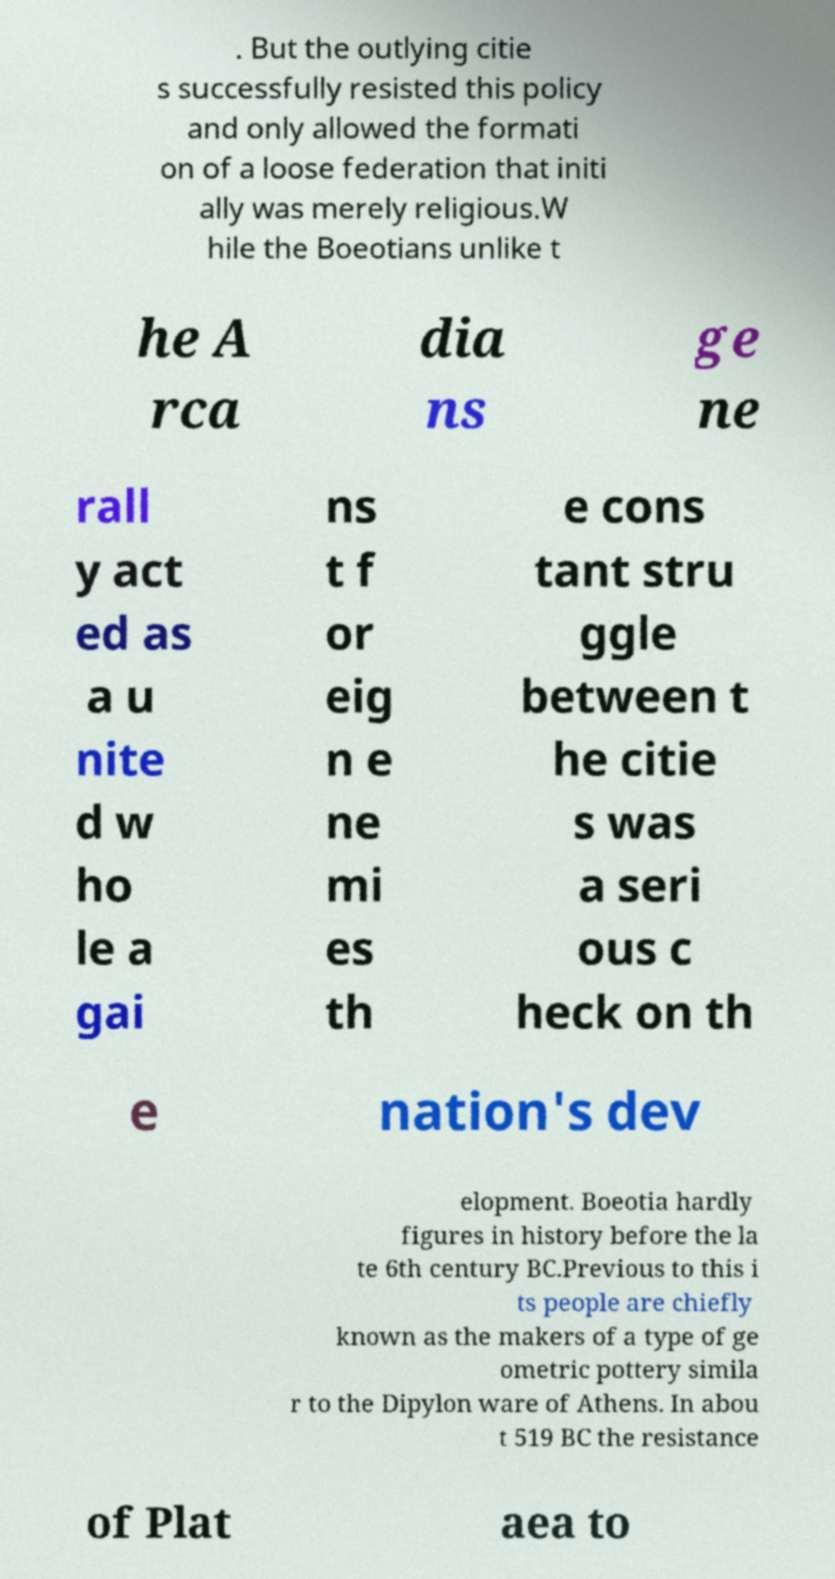Can you accurately transcribe the text from the provided image for me? . But the outlying citie s successfully resisted this policy and only allowed the formati on of a loose federation that initi ally was merely religious.W hile the Boeotians unlike t he A rca dia ns ge ne rall y act ed as a u nite d w ho le a gai ns t f or eig n e ne mi es th e cons tant stru ggle between t he citie s was a seri ous c heck on th e nation's dev elopment. Boeotia hardly figures in history before the la te 6th century BC.Previous to this i ts people are chiefly known as the makers of a type of ge ometric pottery simila r to the Dipylon ware of Athens. In abou t 519 BC the resistance of Plat aea to 